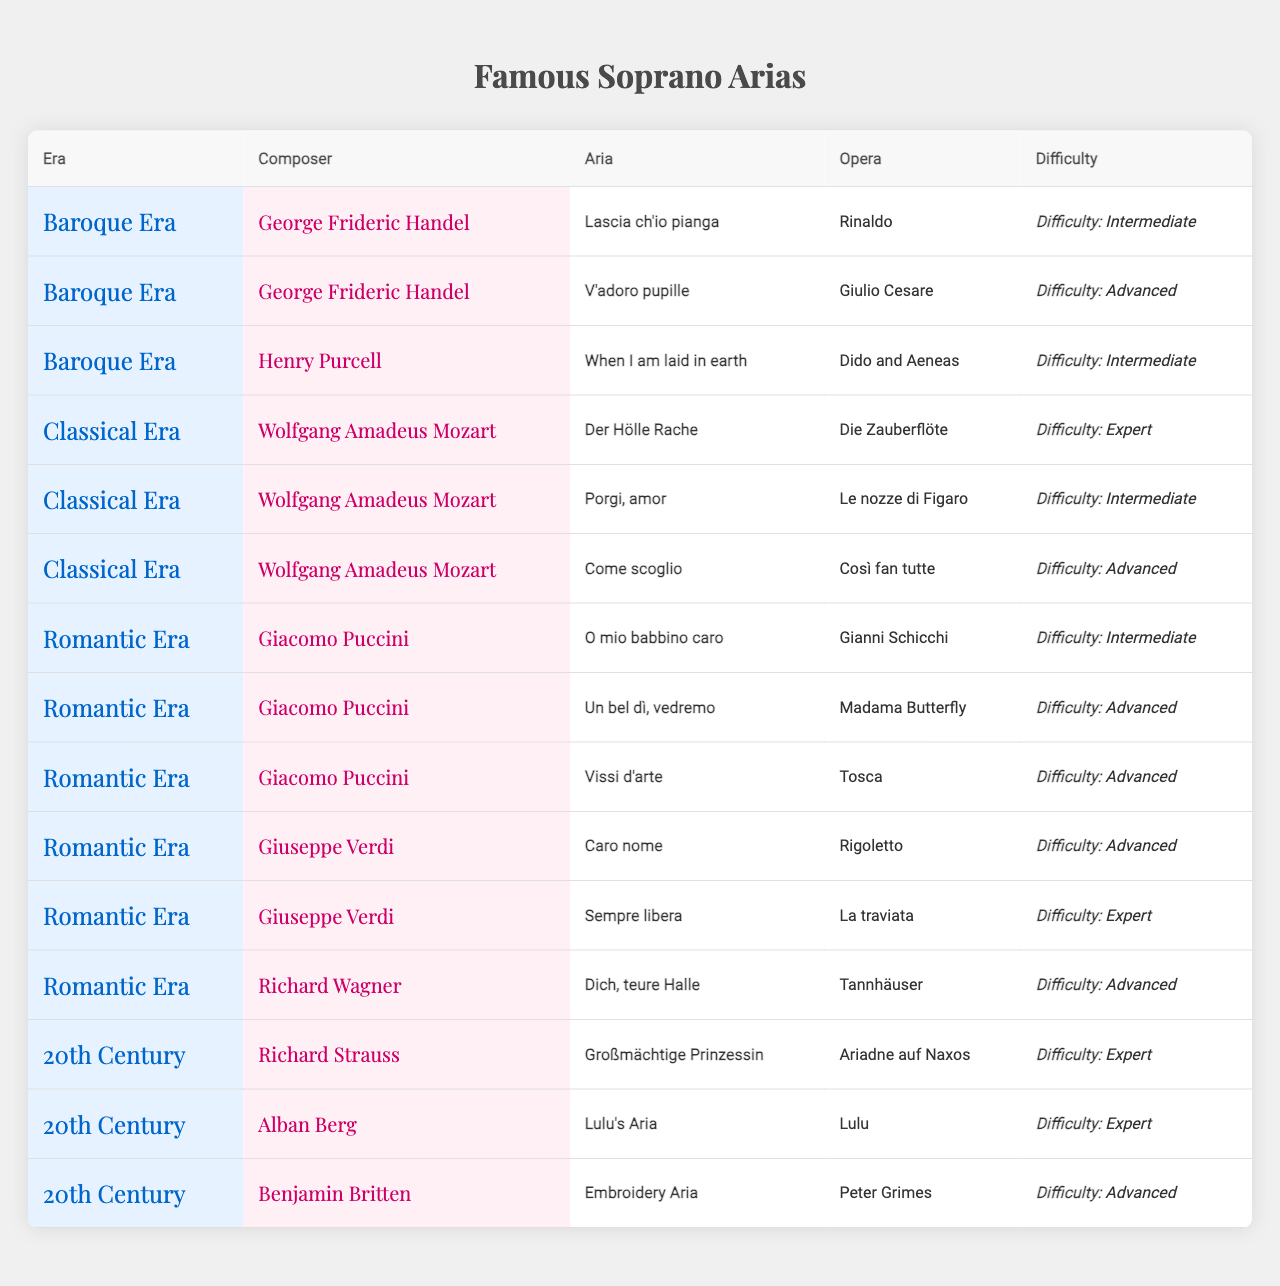What is the easiest aria in the table? The easiest aria can be identified by looking for the lowest difficulty level. In the table, the easiest difficulty level is "Intermediate," which is found in several arias, but specifically, "O mio babbino caro" from "Gianni Schicchi" is listed as an Intermediate level aria.
Answer: O mio babbino caro Which composer has the most advanced arias? To determine which composer has the most advanced arias, we need to count the number of arias categorized as "Advanced" under each composer. Giacomo Puccini and Giuseppe Verdi each have three advanced arias, indicating they are tied for most.
Answer: Giacomo Puccini and Giuseppe Verdi Is there any aria by Handel listed as 'Expert' difficulty? By scanning the table for Handel's entries and checking the difficulty levels associated with his arias, we can see that both arias listed under Handel ("Lascia ch'io pianga" and "V'adoro pupille") are marked as 'Intermediate' and 'Advanced,' respectively. Therefore, there are no arias by Handel listed as 'Expert.'
Answer: No Which era contains the aria "Der Hölle Rache" and what is its difficulty level? "Der Hölle Rache" is located under the composer Wolfgang Amadeus Mozart in the Classical Era category. A quick look confirms the difficulty level stated is 'Expert.'
Answer: Classical Era, Expert How many total Advanced arias are there in the Romantic Era? First, we need to identify and count the arias categorized as 'Advanced' under each composer in the Romantic Era. Giacomo Puccini has two (Un bel dì, vedremo and Vissi d'arte), Giuseppe Verdi has two (Caro nome and Sempre libera), and Richard Wagner has one (Dich, teure Halle). This totals to 2 + 2 + 1 = 5 Advanced arias.
Answer: 5 Which composer has an aria in both Intermediate and Advanced categories? We examine each composer for arias categorized in both difficulty levels. Upon review, Mozart has "Porgi, amor" as Intermediate and "Come scoglio" as Advanced, fitting the criteria discussed.
Answer: Wolfgang Amadeus Mozart What is the name of the aria in the 20th Century by Richard Strauss? In the 20th Century section, we directly look under Richard Strauss to find the aria listed, which is "Großmächtige Prinzessin."
Answer: Großmächtige Prinzessin Are there any arias from the Baroque Era that are classified as 'Expert'? By reviewing the entries in the Baroque Era, we observe that both arias by Handel and Purcell fall under either Intermediate or Advanced, with none marked as 'Expert.' Thus, there are no Expert arias from this era.
Answer: No How many composers are listed under the Romantic Era? To find the number of composers under the Romantic Era, we count the distinct composers present. They are Giacomo Puccini, Giuseppe Verdi, and Richard Wagner, totaling three composers.
Answer: 3 Which aria from the Classical Era has an Intermediate difficulty? Scanning the Classical Era entries reveals that "Porgi, amor" by Wolfgang Amadeus Mozart is noted with an Intermediate difficulty level.
Answer: Porgi, amor 